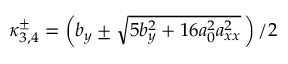<formula> <loc_0><loc_0><loc_500><loc_500>\kappa _ { 3 , 4 } ^ { \pm } = \left ( b _ { y } \pm \sqrt { 5 b _ { y } ^ { 2 } + 1 6 a _ { 0 } ^ { 2 } a _ { x x } ^ { 2 } } \, \right ) / { 2 }</formula> 